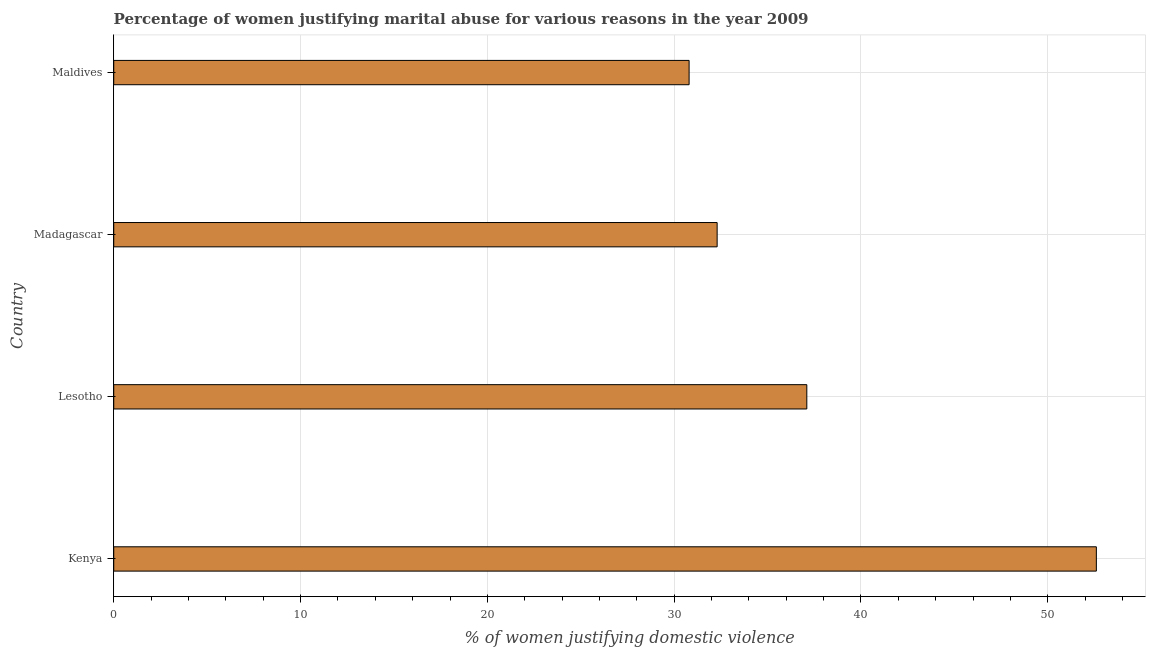Does the graph contain any zero values?
Keep it short and to the point. No. Does the graph contain grids?
Your response must be concise. Yes. What is the title of the graph?
Provide a succinct answer. Percentage of women justifying marital abuse for various reasons in the year 2009. What is the label or title of the X-axis?
Your answer should be very brief. % of women justifying domestic violence. What is the percentage of women justifying marital abuse in Madagascar?
Keep it short and to the point. 32.3. Across all countries, what is the maximum percentage of women justifying marital abuse?
Your answer should be compact. 52.6. Across all countries, what is the minimum percentage of women justifying marital abuse?
Provide a short and direct response. 30.8. In which country was the percentage of women justifying marital abuse maximum?
Your answer should be very brief. Kenya. In which country was the percentage of women justifying marital abuse minimum?
Keep it short and to the point. Maldives. What is the sum of the percentage of women justifying marital abuse?
Your response must be concise. 152.8. What is the average percentage of women justifying marital abuse per country?
Offer a very short reply. 38.2. What is the median percentage of women justifying marital abuse?
Keep it short and to the point. 34.7. What is the ratio of the percentage of women justifying marital abuse in Lesotho to that in Maldives?
Ensure brevity in your answer.  1.21. Is the percentage of women justifying marital abuse in Kenya less than that in Lesotho?
Offer a terse response. No. Is the difference between the percentage of women justifying marital abuse in Kenya and Maldives greater than the difference between any two countries?
Provide a short and direct response. Yes. What is the difference between the highest and the lowest percentage of women justifying marital abuse?
Offer a very short reply. 21.8. How many bars are there?
Your answer should be very brief. 4. How many countries are there in the graph?
Your answer should be compact. 4. What is the difference between two consecutive major ticks on the X-axis?
Your response must be concise. 10. What is the % of women justifying domestic violence of Kenya?
Provide a short and direct response. 52.6. What is the % of women justifying domestic violence of Lesotho?
Your answer should be very brief. 37.1. What is the % of women justifying domestic violence of Madagascar?
Keep it short and to the point. 32.3. What is the % of women justifying domestic violence of Maldives?
Ensure brevity in your answer.  30.8. What is the difference between the % of women justifying domestic violence in Kenya and Lesotho?
Ensure brevity in your answer.  15.5. What is the difference between the % of women justifying domestic violence in Kenya and Madagascar?
Your response must be concise. 20.3. What is the difference between the % of women justifying domestic violence in Kenya and Maldives?
Give a very brief answer. 21.8. What is the difference between the % of women justifying domestic violence in Lesotho and Madagascar?
Give a very brief answer. 4.8. What is the difference between the % of women justifying domestic violence in Lesotho and Maldives?
Ensure brevity in your answer.  6.3. What is the ratio of the % of women justifying domestic violence in Kenya to that in Lesotho?
Make the answer very short. 1.42. What is the ratio of the % of women justifying domestic violence in Kenya to that in Madagascar?
Provide a short and direct response. 1.63. What is the ratio of the % of women justifying domestic violence in Kenya to that in Maldives?
Your answer should be very brief. 1.71. What is the ratio of the % of women justifying domestic violence in Lesotho to that in Madagascar?
Your answer should be compact. 1.15. What is the ratio of the % of women justifying domestic violence in Lesotho to that in Maldives?
Make the answer very short. 1.21. What is the ratio of the % of women justifying domestic violence in Madagascar to that in Maldives?
Make the answer very short. 1.05. 